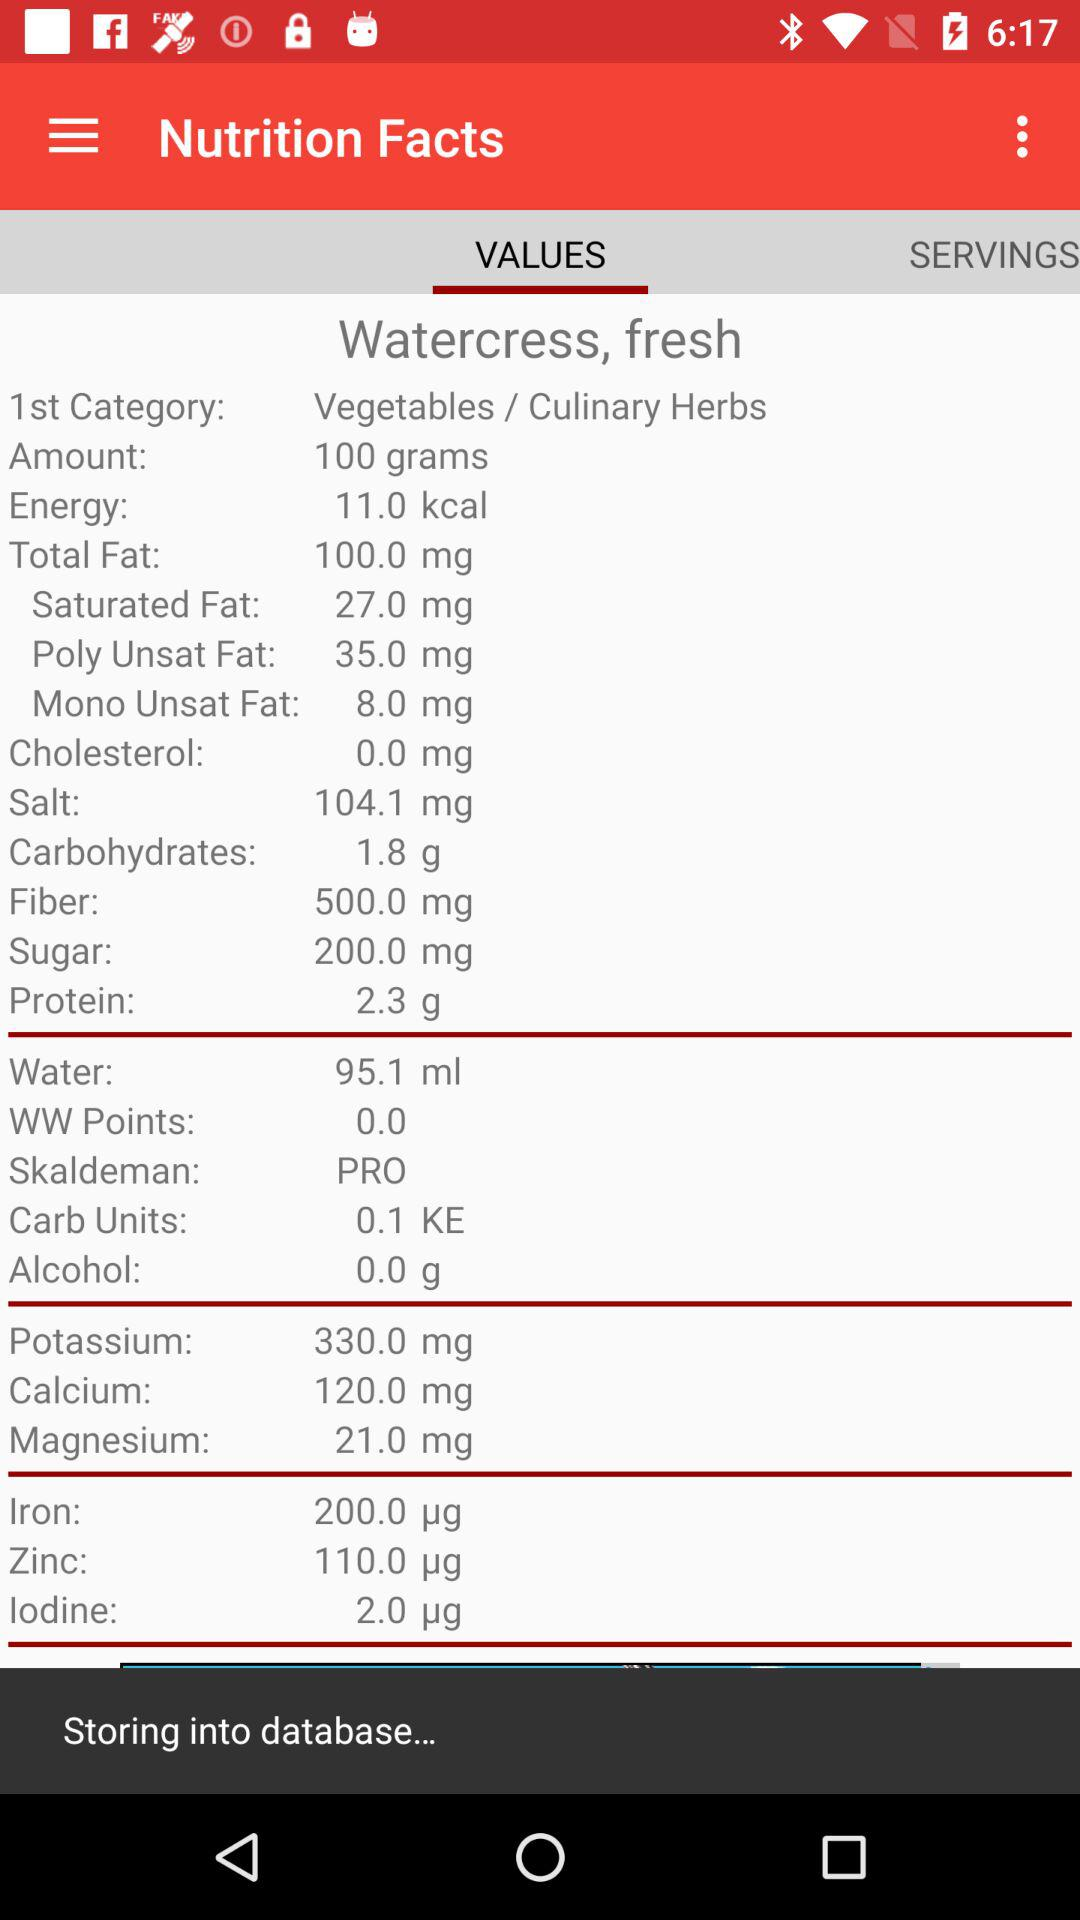How many servings are there?
When the provided information is insufficient, respond with <no answer>. <no answer> 